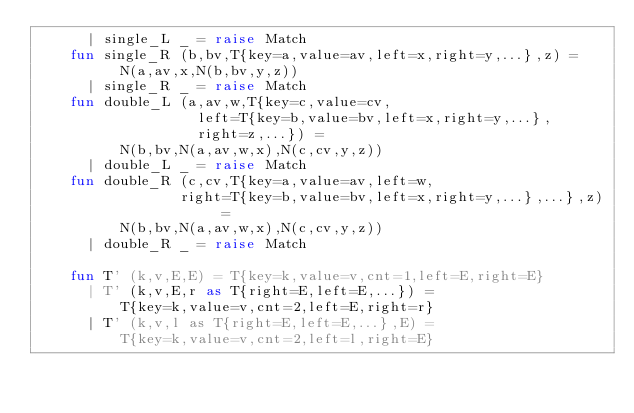<code> <loc_0><loc_0><loc_500><loc_500><_SML_>	  | single_L _ = raise Match
	fun single_R (b,bv,T{key=a,value=av,left=x,right=y,...},z) = 
	      N(a,av,x,N(b,bv,y,z))
	  | single_R _ = raise Match
	fun double_L (a,av,w,T{key=c,value=cv, 
			       left=T{key=b,value=bv,left=x,right=y,...},
			       right=z,...}) =
	      N(b,bv,N(a,av,w,x),N(c,cv,y,z))
	  | double_L _ = raise Match
	fun double_R (c,cv,T{key=a,value=av,left=w,
			     right=T{key=b,value=bv,left=x,right=y,...},...},z) = 
	      N(b,bv,N(a,av,w,x),N(c,cv,y,z))
	  | double_R _ = raise Match

	fun T' (k,v,E,E) = T{key=k,value=v,cnt=1,left=E,right=E}
	  | T' (k,v,E,r as T{right=E,left=E,...}) =
	      T{key=k,value=v,cnt=2,left=E,right=r}
	  | T' (k,v,l as T{right=E,left=E,...},E) =
	      T{key=k,value=v,cnt=2,left=l,right=E}
</code> 